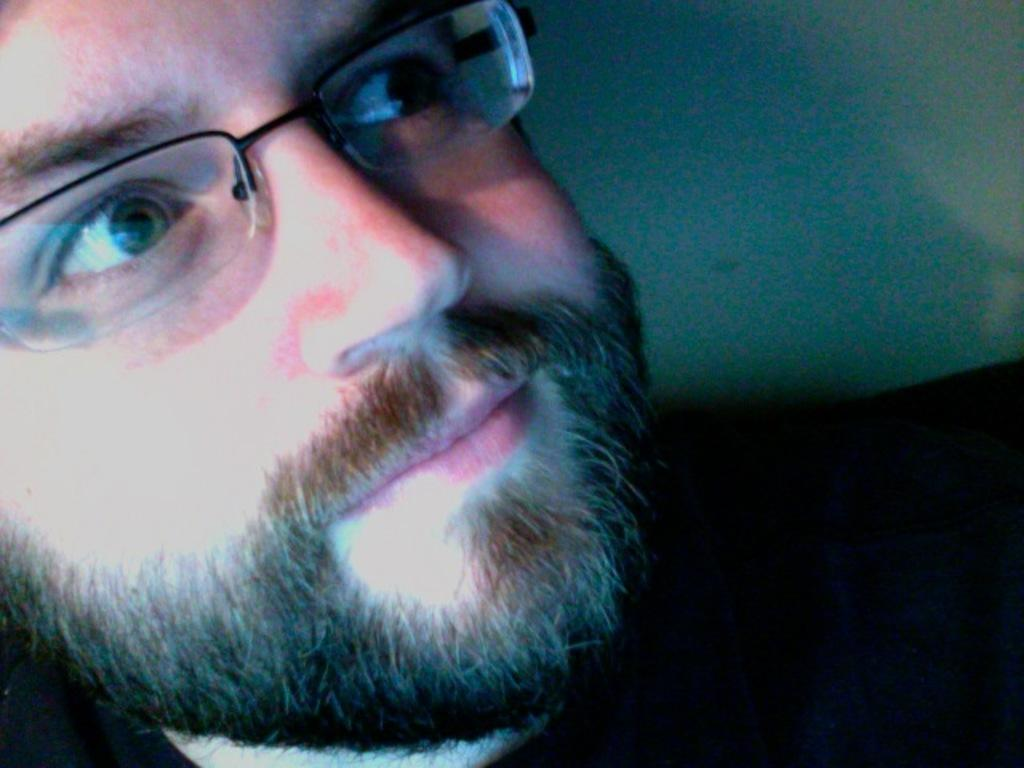What is the main subject of the image? There is a person in the image. Can you describe the person's appearance? The person is wearing specs. What type of birds can be seen flying in the image? There are no birds visible in the image; it only features a person wearing specs. What is the person's emotional state in the image? The image does not provide any information about the person's emotional state, such as fear. 